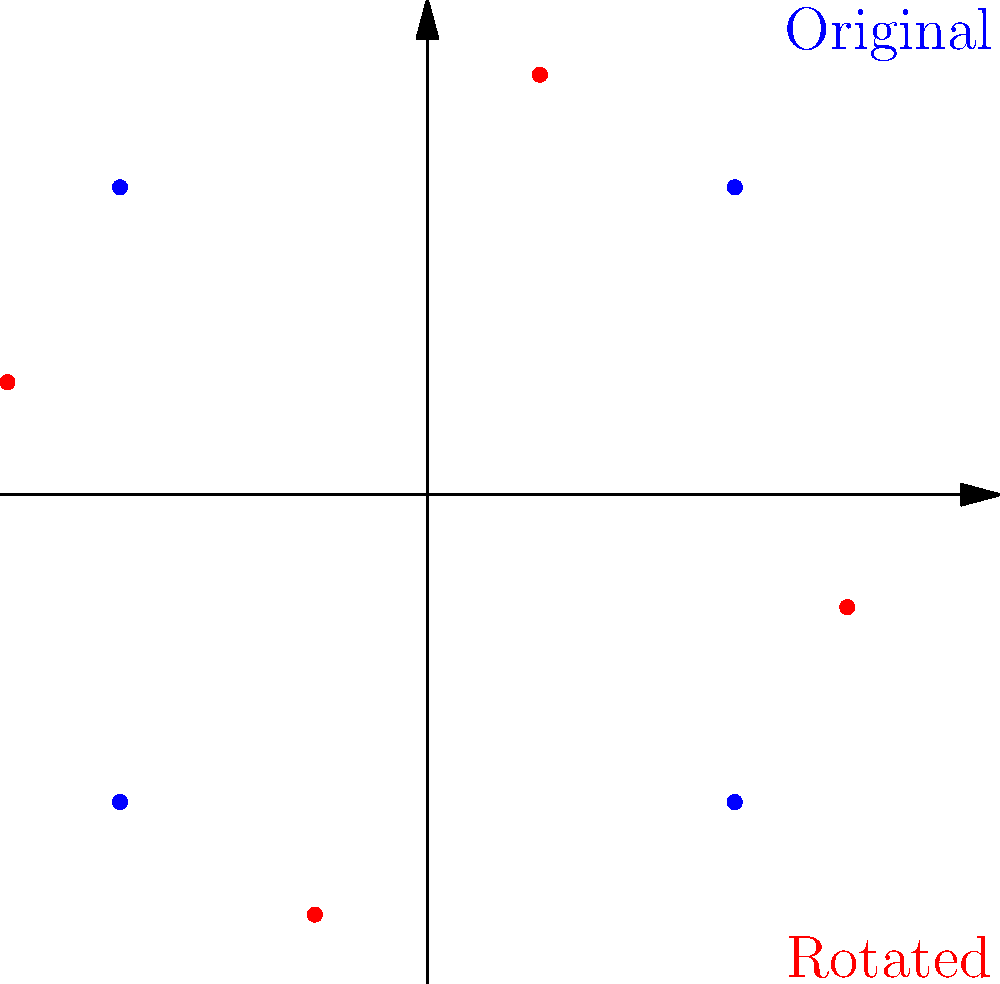Given two QPSK constellations represented by the blue and red scatter plots, determine the clockwise rotation angle (in degrees) needed to align the red constellation with the blue one. Assume both constellations are centered at the origin and have the same scale. To find the rotation angle, we can follow these steps:

1) Observe that both constellations represent QPSK modulation, with four points each.

2) The blue constellation is in the standard QPSK configuration, with points at (1,1), (-1,1), (-1,-1), and (1,-1).

3) The red constellation appears to be a rotated version of the blue one.

4) To determine the rotation angle, we can focus on one point, say the one in the first quadrant.

5) In the blue constellation, this point is at (1,1).

6) In the red constellation, this point has been rotated clockwise.

7) The angle of rotation can be calculated using the arctangent function:
   $$\theta = \arctan(\frac{y}{x}) = \arctan(\frac{\sqrt{3}}{1}) = 30°$$

8) We can verify this by applying a 30° clockwise rotation to all points of the blue constellation:
   $$x' = x \cos(\theta) + y \sin(\theta)$$
   $$y' = -x \sin(\theta) + y \cos(\theta)$$

9) This rotation indeed aligns the blue constellation with the red one.

Therefore, a 30° clockwise rotation is needed to align the red constellation with the blue one.
Answer: 30° 